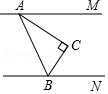How might this angle configuration be useful in real-world applications? This type of angle configuration and geometry can be useful in real-world scenarios like architectural design, where ensuring precise angles in the structure of roofs or walls is crucial for stability and aesthetic appeal. Additionally, the principles of parallel lines and angles play a significant role in fields such as civil engineering, graphic design, and even physics, where understanding the relationships between various components in space is essential. 